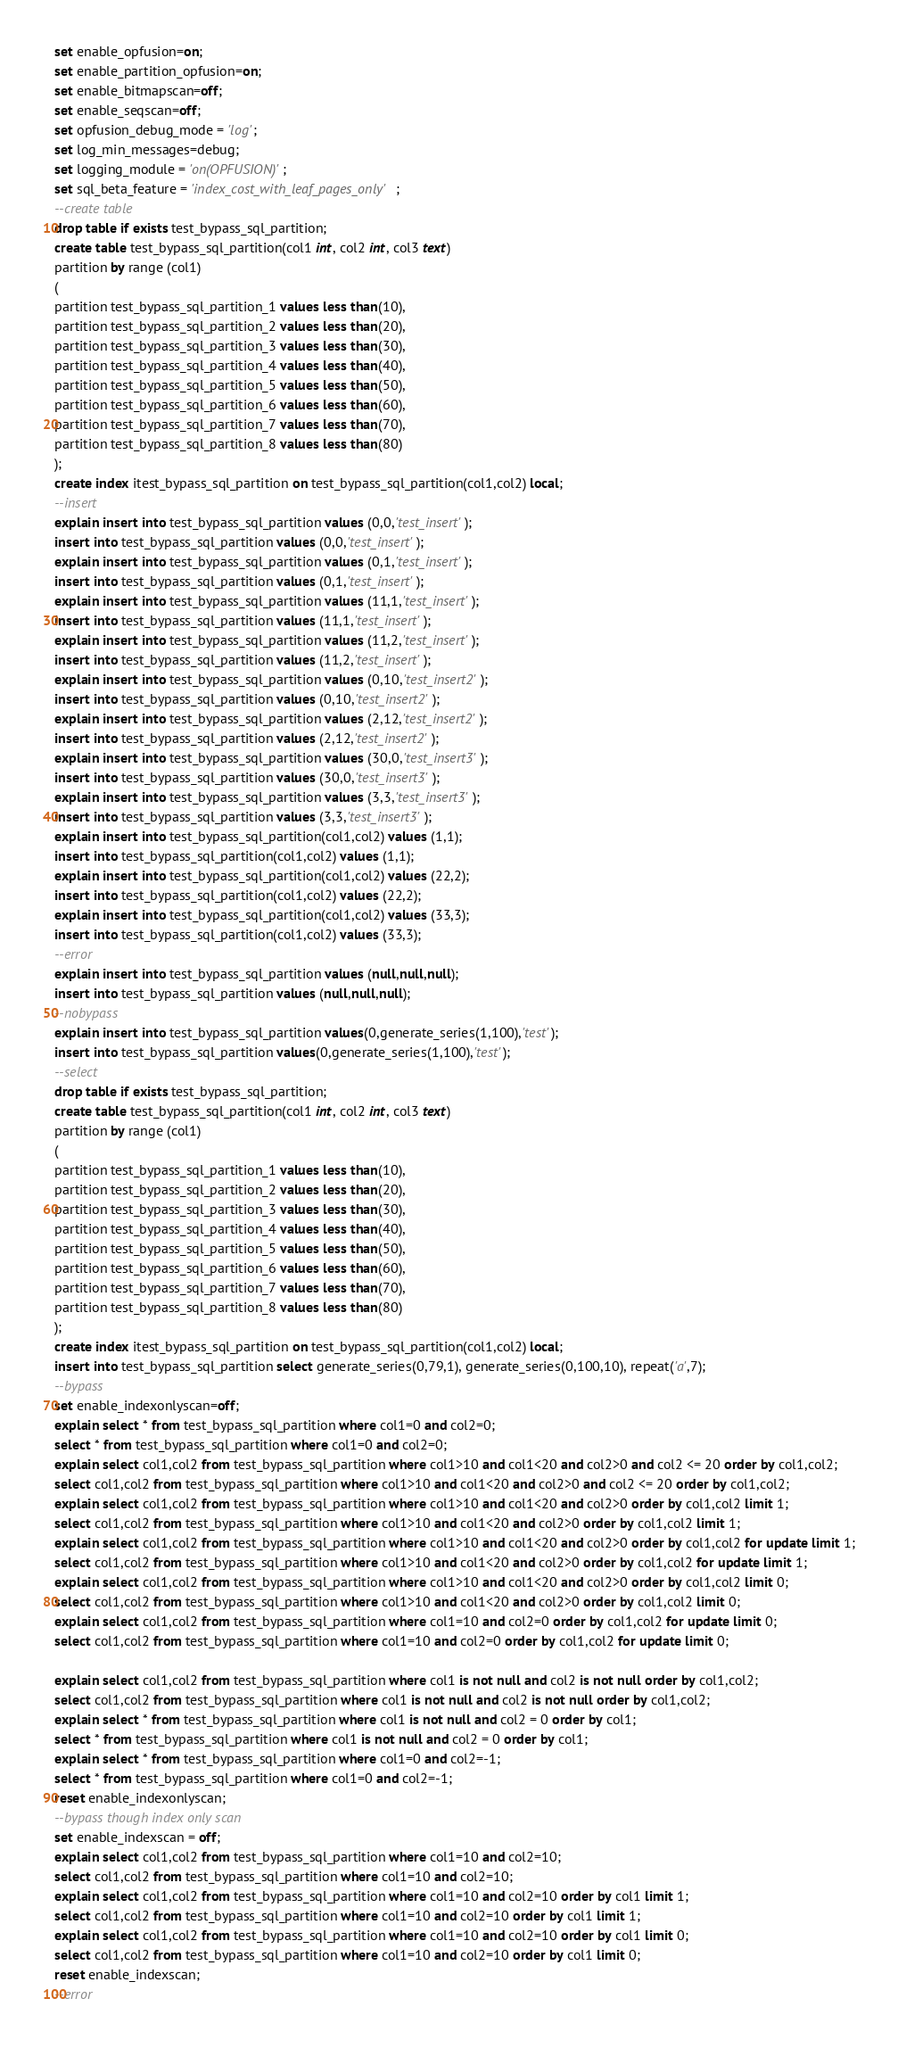Convert code to text. <code><loc_0><loc_0><loc_500><loc_500><_SQL_>set enable_opfusion=on;
set enable_partition_opfusion=on;
set enable_bitmapscan=off;
set enable_seqscan=off;
set opfusion_debug_mode = 'log';
set log_min_messages=debug;
set logging_module = 'on(OPFUSION)';
set sql_beta_feature = 'index_cost_with_leaf_pages_only';
--create table
drop table if exists test_bypass_sql_partition;
create table test_bypass_sql_partition(col1 int, col2 int, col3 text)
partition by range (col1)
(
partition test_bypass_sql_partition_1 values less than(10),
partition test_bypass_sql_partition_2 values less than(20),
partition test_bypass_sql_partition_3 values less than(30),
partition test_bypass_sql_partition_4 values less than(40),
partition test_bypass_sql_partition_5 values less than(50),
partition test_bypass_sql_partition_6 values less than(60),
partition test_bypass_sql_partition_7 values less than(70),
partition test_bypass_sql_partition_8 values less than(80)
);
create index itest_bypass_sql_partition on test_bypass_sql_partition(col1,col2) local;
--insert
explain insert into test_bypass_sql_partition values (0,0,'test_insert');
insert into test_bypass_sql_partition values (0,0,'test_insert');
explain insert into test_bypass_sql_partition values (0,1,'test_insert');
insert into test_bypass_sql_partition values (0,1,'test_insert');
explain insert into test_bypass_sql_partition values (11,1,'test_insert');
insert into test_bypass_sql_partition values (11,1,'test_insert');
explain insert into test_bypass_sql_partition values (11,2,'test_insert');
insert into test_bypass_sql_partition values (11,2,'test_insert');
explain insert into test_bypass_sql_partition values (0,10,'test_insert2');
insert into test_bypass_sql_partition values (0,10,'test_insert2');
explain insert into test_bypass_sql_partition values (2,12,'test_insert2');
insert into test_bypass_sql_partition values (2,12,'test_insert2');
explain insert into test_bypass_sql_partition values (30,0,'test_insert3');
insert into test_bypass_sql_partition values (30,0,'test_insert3');
explain insert into test_bypass_sql_partition values (3,3,'test_insert3');
insert into test_bypass_sql_partition values (3,3,'test_insert3');
explain insert into test_bypass_sql_partition(col1,col2) values (1,1);
insert into test_bypass_sql_partition(col1,col2) values (1,1);
explain insert into test_bypass_sql_partition(col1,col2) values (22,2);
insert into test_bypass_sql_partition(col1,col2) values (22,2);
explain insert into test_bypass_sql_partition(col1,col2) values (33,3);
insert into test_bypass_sql_partition(col1,col2) values (33,3);
--error
explain insert into test_bypass_sql_partition values (null,null,null);
insert into test_bypass_sql_partition values (null,null,null);
--nobypass
explain insert into test_bypass_sql_partition values(0,generate_series(1,100),'test');
insert into test_bypass_sql_partition values(0,generate_series(1,100),'test');
--select
drop table if exists test_bypass_sql_partition;
create table test_bypass_sql_partition(col1 int, col2 int, col3 text)
partition by range (col1)
(
partition test_bypass_sql_partition_1 values less than(10),
partition test_bypass_sql_partition_2 values less than(20),
partition test_bypass_sql_partition_3 values less than(30),
partition test_bypass_sql_partition_4 values less than(40),
partition test_bypass_sql_partition_5 values less than(50),
partition test_bypass_sql_partition_6 values less than(60),
partition test_bypass_sql_partition_7 values less than(70),
partition test_bypass_sql_partition_8 values less than(80)
);
create index itest_bypass_sql_partition on test_bypass_sql_partition(col1,col2) local;
insert into test_bypass_sql_partition select generate_series(0,79,1), generate_series(0,100,10), repeat('a',7);
--bypass
set enable_indexonlyscan=off;
explain select * from test_bypass_sql_partition where col1=0 and col2=0;
select * from test_bypass_sql_partition where col1=0 and col2=0;
explain select col1,col2 from test_bypass_sql_partition where col1>10 and col1<20 and col2>0 and col2 <= 20 order by col1,col2;
select col1,col2 from test_bypass_sql_partition where col1>10 and col1<20 and col2>0 and col2 <= 20 order by col1,col2;
explain select col1,col2 from test_bypass_sql_partition where col1>10 and col1<20 and col2>0 order by col1,col2 limit 1;
select col1,col2 from test_bypass_sql_partition where col1>10 and col1<20 and col2>0 order by col1,col2 limit 1;
explain select col1,col2 from test_bypass_sql_partition where col1>10 and col1<20 and col2>0 order by col1,col2 for update limit 1;
select col1,col2 from test_bypass_sql_partition where col1>10 and col1<20 and col2>0 order by col1,col2 for update limit 1;
explain select col1,col2 from test_bypass_sql_partition where col1>10 and col1<20 and col2>0 order by col1,col2 limit 0;
select col1,col2 from test_bypass_sql_partition where col1>10 and col1<20 and col2>0 order by col1,col2 limit 0;
explain select col1,col2 from test_bypass_sql_partition where col1=10 and col2=0 order by col1,col2 for update limit 0;
select col1,col2 from test_bypass_sql_partition where col1=10 and col2=0 order by col1,col2 for update limit 0;

explain select col1,col2 from test_bypass_sql_partition where col1 is not null and col2 is not null order by col1,col2;
select col1,col2 from test_bypass_sql_partition where col1 is not null and col2 is not null order by col1,col2;
explain select * from test_bypass_sql_partition where col1 is not null and col2 = 0 order by col1;
select * from test_bypass_sql_partition where col1 is not null and col2 = 0 order by col1;
explain select * from test_bypass_sql_partition where col1=0 and col2=-1;
select * from test_bypass_sql_partition where col1=0 and col2=-1;
reset enable_indexonlyscan;
--bypass though index only scan
set enable_indexscan = off;
explain select col1,col2 from test_bypass_sql_partition where col1=10 and col2=10;
select col1,col2 from test_bypass_sql_partition where col1=10 and col2=10;
explain select col1,col2 from test_bypass_sql_partition where col1=10 and col2=10 order by col1 limit 1;
select col1,col2 from test_bypass_sql_partition where col1=10 and col2=10 order by col1 limit 1;
explain select col1,col2 from test_bypass_sql_partition where col1=10 and col2=10 order by col1 limit 0;
select col1,col2 from test_bypass_sql_partition where col1=10 and col2=10 order by col1 limit 0;
reset enable_indexscan;
--error</code> 